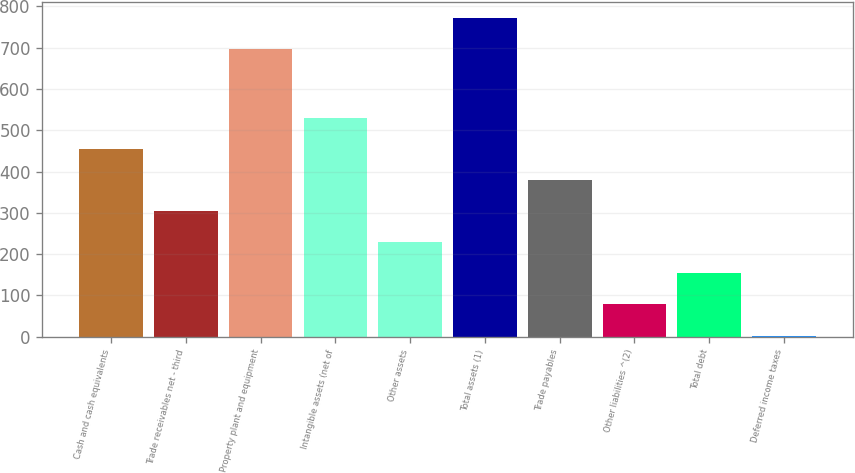Convert chart. <chart><loc_0><loc_0><loc_500><loc_500><bar_chart><fcel>Cash and cash equivalents<fcel>Trade receivables net - third<fcel>Property plant and equipment<fcel>Intangible assets (net of<fcel>Other assets<fcel>Total assets (1)<fcel>Trade payables<fcel>Other liabilities ^(2)<fcel>Total debt<fcel>Deferred income taxes<nl><fcel>454.8<fcel>304.2<fcel>697<fcel>530.1<fcel>228.9<fcel>772.3<fcel>379.5<fcel>78.3<fcel>153.6<fcel>3<nl></chart> 